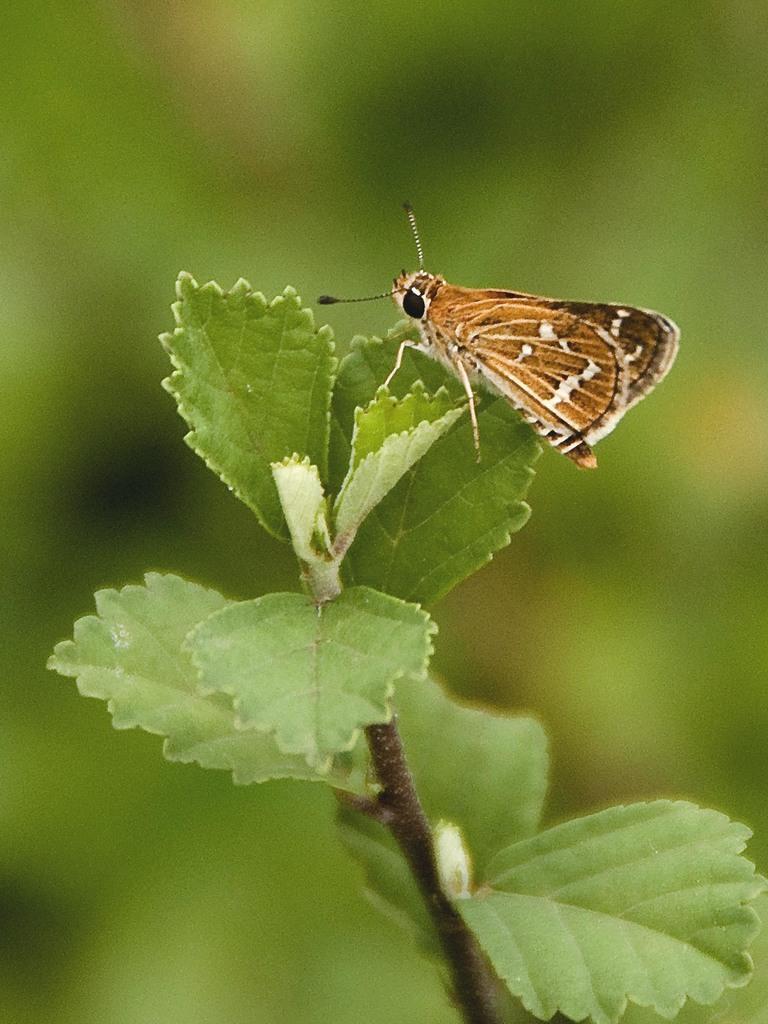Could you give a brief overview of what you see in this image? In this image we can see a fly on the leaf. At the bottom there is a plant. 